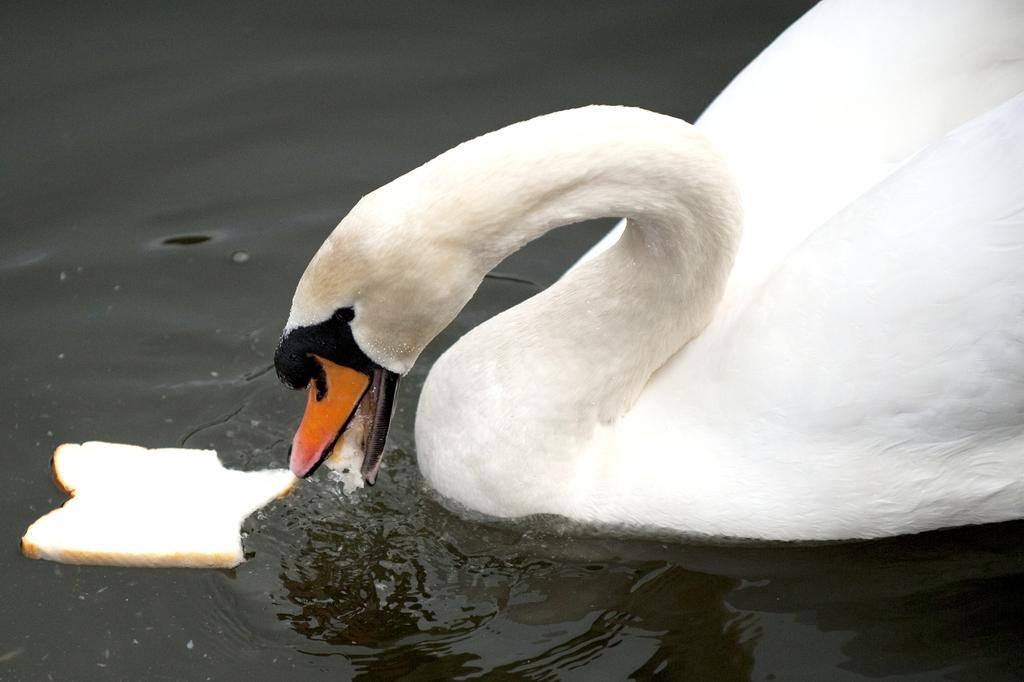What animal is present in the image? There is a swan in the image. Where is the swan located? The swan is in the water. What object is in the image, and where is it placed? There is a piece of bread in the image, and it is in front of the swan. What type of cub can be seen playing with the swan in the image? There is no cub present in the image, and the swan is not shown playing with any other animals. 